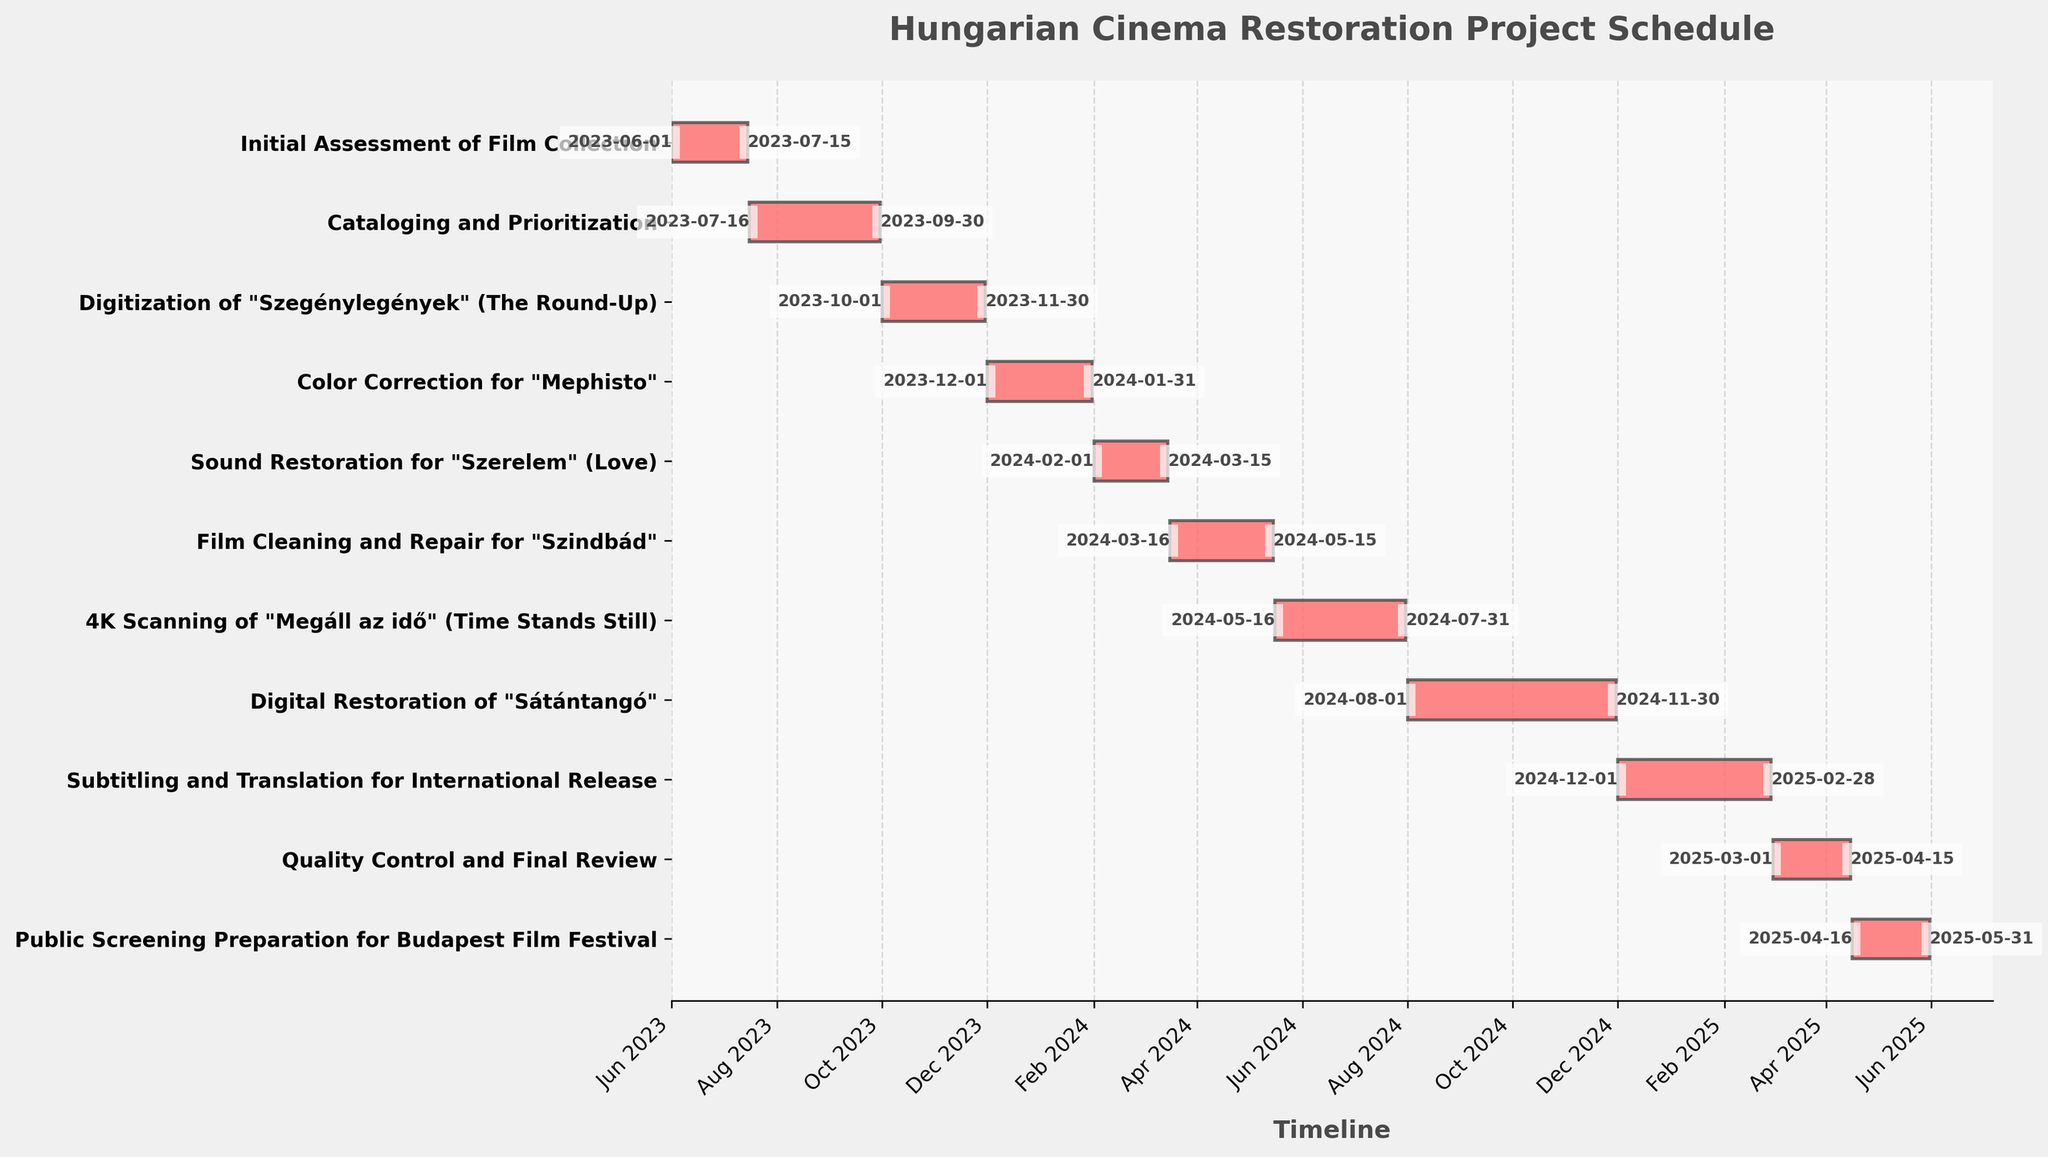When does the "Quality Control and Final Review" phase start and end? The "Quality Control and Final Review" phase has labeled start and end dates on the figure, starting on 2025-03-01 and ending on 2025-04-15.
Answer: 2025-03-01 to 2025-04-15 How long does the digitization of "Szegénylegények" (The Round-Up) take? The duration of the "Digitization of 'Szegénylegények' (The Round-Up)" can be seen between the start date (2023-10-01) and end date (2023-11-30). Subtracting these dates gives the total duration.
Answer: 61 days Which phase is longer, "Cataloging and Prioritization" or "Public Screening Preparation for Budapest Film Festival"? Compare the duration of "Cataloging and Prioritization" (start: 2023-07-16, end: 2023-09-30) and "Public Screening Preparation for Budapest Film Festival" (start: 2025-04-16, end: 2025-05-31). The "Cataloging and Prioritization" phase takes 76 days, while the "Public Screening Preparation" takes 46 days.
Answer: Cataloging and Prioritization What are the tasks overlapping with "Film Cleaning and Repair for 'Szindbád'"? Identify the tasks whose time periods overlap with "Film Cleaning and Repair for 'Szindbád'" (2024-03-16 to 2024-05-15). This period overlaps with the end of "Sound Restoration for 'Szerelem'" (until 2024-03-15) and the start of "4K Scanning of 'Megáll az idő'" (from 2024-05-16).
Answer: Sound Restoration for 'Szerelem' and 4K Scanning of 'Megáll az idő' During which months of 2024 does the "Digital Restoration of 'Sátántangó'" take place? "Digital Restoration of 'Sátántangó'" starts on 2024-08-01 and ends on 2024-11-30. Hence, it takes place from August to November 2024.
Answer: August to November 2024 What's the total duration of the "Subtitling and Translation for International Release" phase in months? The "Subtitling and Translation for International Release" phase starts on 2024-12-01 and ends on 2025-02-28. Counting the months from December to February gives a total of 3 months.
Answer: 3 months Which task starts immediately after "Color Correction for 'Mephisto'" ends? "Color Correction for 'Mephisto'" ends on 2024-01-31. The task that starts immediately after is "Sound Restoration for 'Szerelem'", starting on 2024-02-01.
Answer: Sound Restoration for 'Szerelem' How many tasks start in 2023? Identify tasks whose start dates fall within 2023. These include "Initial Assessment of Film Collection", "Cataloging and Prioritization", and "Digitization of 'Szegénylegények' (The Round-Up)".
Answer: 3 tasks Is the color correction phase longer than the sound restoration phase? Compare the duration of "Color Correction for 'Mephisto'" (2023-12-01 to 2024-01-31, 62 days) and "Sound Restoration for 'Szerelem'" (2024-02-01 to 2024-03-15, 44 days). "Color Correction for 'Mephisto'" is longer.
Answer: Yes, Color Correction for 'Mephisto' is longer What is the last scheduled task? The last task listed on the chart is "Public Screening Preparation for Budapest Film Festival", which ends on 2025-05-31.
Answer: Public Screening Preparation for Budapest Film Festival 